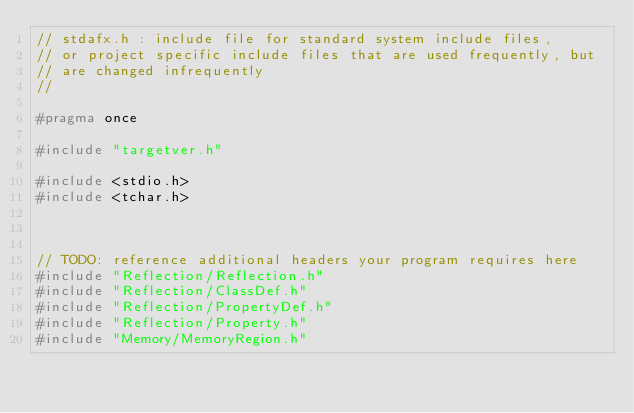Convert code to text. <code><loc_0><loc_0><loc_500><loc_500><_C_>// stdafx.h : include file for standard system include files,
// or project specific include files that are used frequently, but
// are changed infrequently
//

#pragma once

#include "targetver.h"

#include <stdio.h>
#include <tchar.h>



// TODO: reference additional headers your program requires here
#include "Reflection/Reflection.h"
#include "Reflection/ClassDef.h"
#include "Reflection/PropertyDef.h"
#include "Reflection/Property.h"
#include "Memory/MemoryRegion.h"</code> 